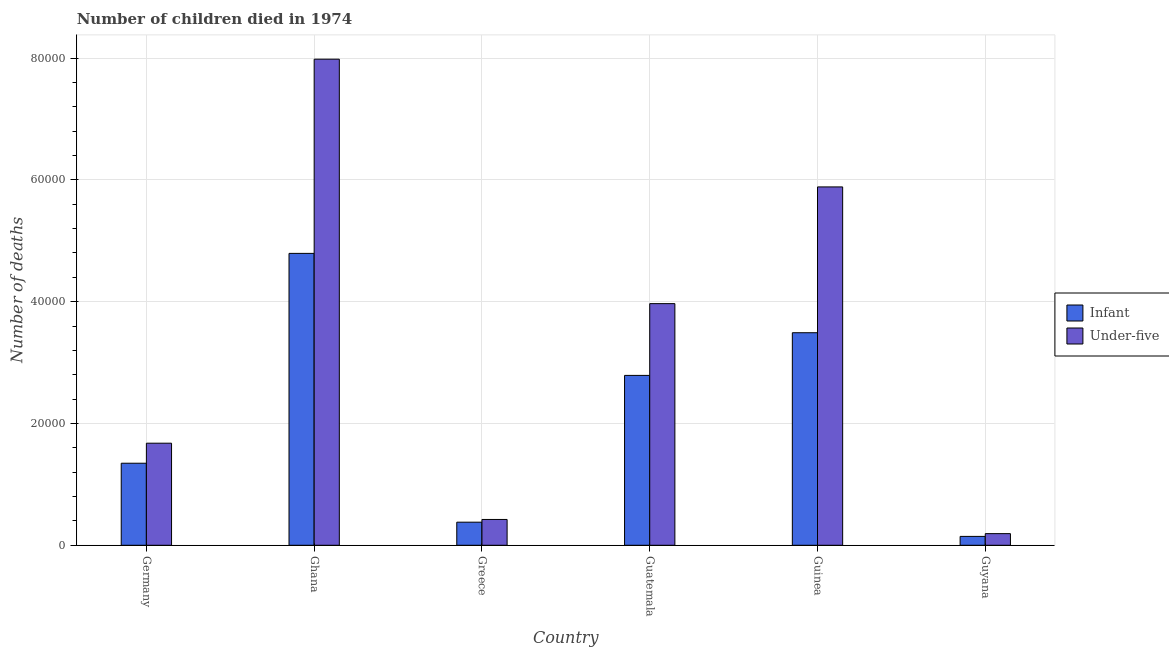How many different coloured bars are there?
Provide a short and direct response. 2. Are the number of bars per tick equal to the number of legend labels?
Your response must be concise. Yes. How many bars are there on the 3rd tick from the left?
Give a very brief answer. 2. What is the label of the 6th group of bars from the left?
Make the answer very short. Guyana. What is the number of infant deaths in Guatemala?
Keep it short and to the point. 2.79e+04. Across all countries, what is the maximum number of infant deaths?
Provide a succinct answer. 4.79e+04. Across all countries, what is the minimum number of under-five deaths?
Ensure brevity in your answer.  1912. In which country was the number of under-five deaths minimum?
Provide a short and direct response. Guyana. What is the total number of under-five deaths in the graph?
Your response must be concise. 2.01e+05. What is the difference between the number of under-five deaths in Germany and that in Ghana?
Make the answer very short. -6.30e+04. What is the difference between the number of infant deaths in Guinea and the number of under-five deaths in Guatemala?
Your answer should be compact. -4776. What is the average number of under-five deaths per country?
Keep it short and to the point. 3.35e+04. What is the difference between the number of infant deaths and number of under-five deaths in Germany?
Your answer should be compact. -3290. In how many countries, is the number of under-five deaths greater than 4000 ?
Provide a succinct answer. 5. What is the ratio of the number of infant deaths in Ghana to that in Guyana?
Your answer should be very brief. 32.89. Is the number of infant deaths in Guatemala less than that in Guyana?
Offer a very short reply. No. Is the difference between the number of infant deaths in Guinea and Guyana greater than the difference between the number of under-five deaths in Guinea and Guyana?
Provide a succinct answer. No. What is the difference between the highest and the second highest number of under-five deaths?
Ensure brevity in your answer.  2.10e+04. What is the difference between the highest and the lowest number of under-five deaths?
Provide a short and direct response. 7.79e+04. In how many countries, is the number of infant deaths greater than the average number of infant deaths taken over all countries?
Your answer should be very brief. 3. What does the 1st bar from the left in Guatemala represents?
Your response must be concise. Infant. What does the 1st bar from the right in Greece represents?
Give a very brief answer. Under-five. How many bars are there?
Offer a terse response. 12. Are all the bars in the graph horizontal?
Provide a succinct answer. No. Are the values on the major ticks of Y-axis written in scientific E-notation?
Your response must be concise. No. Does the graph contain any zero values?
Provide a short and direct response. No. How many legend labels are there?
Offer a very short reply. 2. What is the title of the graph?
Ensure brevity in your answer.  Number of children died in 1974. What is the label or title of the X-axis?
Give a very brief answer. Country. What is the label or title of the Y-axis?
Offer a very short reply. Number of deaths. What is the Number of deaths in Infant in Germany?
Offer a terse response. 1.35e+04. What is the Number of deaths in Under-five in Germany?
Your answer should be very brief. 1.68e+04. What is the Number of deaths in Infant in Ghana?
Ensure brevity in your answer.  4.79e+04. What is the Number of deaths of Under-five in Ghana?
Keep it short and to the point. 7.98e+04. What is the Number of deaths of Infant in Greece?
Your response must be concise. 3792. What is the Number of deaths in Under-five in Greece?
Your response must be concise. 4239. What is the Number of deaths in Infant in Guatemala?
Offer a very short reply. 2.79e+04. What is the Number of deaths in Under-five in Guatemala?
Your answer should be compact. 3.97e+04. What is the Number of deaths in Infant in Guinea?
Your answer should be compact. 3.49e+04. What is the Number of deaths of Under-five in Guinea?
Provide a succinct answer. 5.88e+04. What is the Number of deaths of Infant in Guyana?
Ensure brevity in your answer.  1457. What is the Number of deaths of Under-five in Guyana?
Make the answer very short. 1912. Across all countries, what is the maximum Number of deaths in Infant?
Make the answer very short. 4.79e+04. Across all countries, what is the maximum Number of deaths in Under-five?
Offer a very short reply. 7.98e+04. Across all countries, what is the minimum Number of deaths in Infant?
Your answer should be compact. 1457. Across all countries, what is the minimum Number of deaths in Under-five?
Your response must be concise. 1912. What is the total Number of deaths in Infant in the graph?
Make the answer very short. 1.29e+05. What is the total Number of deaths in Under-five in the graph?
Provide a short and direct response. 2.01e+05. What is the difference between the Number of deaths in Infant in Germany and that in Ghana?
Provide a succinct answer. -3.45e+04. What is the difference between the Number of deaths in Under-five in Germany and that in Ghana?
Provide a short and direct response. -6.30e+04. What is the difference between the Number of deaths of Infant in Germany and that in Greece?
Make the answer very short. 9678. What is the difference between the Number of deaths in Under-five in Germany and that in Greece?
Keep it short and to the point. 1.25e+04. What is the difference between the Number of deaths in Infant in Germany and that in Guatemala?
Offer a terse response. -1.44e+04. What is the difference between the Number of deaths of Under-five in Germany and that in Guatemala?
Your response must be concise. -2.29e+04. What is the difference between the Number of deaths of Infant in Germany and that in Guinea?
Make the answer very short. -2.14e+04. What is the difference between the Number of deaths of Under-five in Germany and that in Guinea?
Offer a very short reply. -4.21e+04. What is the difference between the Number of deaths of Infant in Germany and that in Guyana?
Keep it short and to the point. 1.20e+04. What is the difference between the Number of deaths of Under-five in Germany and that in Guyana?
Ensure brevity in your answer.  1.48e+04. What is the difference between the Number of deaths in Infant in Ghana and that in Greece?
Give a very brief answer. 4.41e+04. What is the difference between the Number of deaths in Under-five in Ghana and that in Greece?
Offer a terse response. 7.56e+04. What is the difference between the Number of deaths in Infant in Ghana and that in Guatemala?
Provide a short and direct response. 2.00e+04. What is the difference between the Number of deaths of Under-five in Ghana and that in Guatemala?
Provide a succinct answer. 4.01e+04. What is the difference between the Number of deaths in Infant in Ghana and that in Guinea?
Make the answer very short. 1.30e+04. What is the difference between the Number of deaths in Under-five in Ghana and that in Guinea?
Offer a very short reply. 2.10e+04. What is the difference between the Number of deaths of Infant in Ghana and that in Guyana?
Ensure brevity in your answer.  4.65e+04. What is the difference between the Number of deaths of Under-five in Ghana and that in Guyana?
Your answer should be compact. 7.79e+04. What is the difference between the Number of deaths of Infant in Greece and that in Guatemala?
Your answer should be compact. -2.41e+04. What is the difference between the Number of deaths in Under-five in Greece and that in Guatemala?
Your response must be concise. -3.54e+04. What is the difference between the Number of deaths of Infant in Greece and that in Guinea?
Your answer should be very brief. -3.11e+04. What is the difference between the Number of deaths of Under-five in Greece and that in Guinea?
Make the answer very short. -5.46e+04. What is the difference between the Number of deaths in Infant in Greece and that in Guyana?
Your answer should be very brief. 2335. What is the difference between the Number of deaths in Under-five in Greece and that in Guyana?
Offer a very short reply. 2327. What is the difference between the Number of deaths of Infant in Guatemala and that in Guinea?
Keep it short and to the point. -7005. What is the difference between the Number of deaths in Under-five in Guatemala and that in Guinea?
Your answer should be very brief. -1.92e+04. What is the difference between the Number of deaths in Infant in Guatemala and that in Guyana?
Your answer should be compact. 2.64e+04. What is the difference between the Number of deaths of Under-five in Guatemala and that in Guyana?
Give a very brief answer. 3.78e+04. What is the difference between the Number of deaths in Infant in Guinea and that in Guyana?
Keep it short and to the point. 3.34e+04. What is the difference between the Number of deaths of Under-five in Guinea and that in Guyana?
Make the answer very short. 5.69e+04. What is the difference between the Number of deaths in Infant in Germany and the Number of deaths in Under-five in Ghana?
Your answer should be very brief. -6.63e+04. What is the difference between the Number of deaths of Infant in Germany and the Number of deaths of Under-five in Greece?
Ensure brevity in your answer.  9231. What is the difference between the Number of deaths of Infant in Germany and the Number of deaths of Under-five in Guatemala?
Offer a terse response. -2.62e+04. What is the difference between the Number of deaths of Infant in Germany and the Number of deaths of Under-five in Guinea?
Give a very brief answer. -4.54e+04. What is the difference between the Number of deaths of Infant in Germany and the Number of deaths of Under-five in Guyana?
Provide a succinct answer. 1.16e+04. What is the difference between the Number of deaths in Infant in Ghana and the Number of deaths in Under-five in Greece?
Ensure brevity in your answer.  4.37e+04. What is the difference between the Number of deaths in Infant in Ghana and the Number of deaths in Under-five in Guatemala?
Provide a short and direct response. 8252. What is the difference between the Number of deaths of Infant in Ghana and the Number of deaths of Under-five in Guinea?
Provide a short and direct response. -1.09e+04. What is the difference between the Number of deaths in Infant in Ghana and the Number of deaths in Under-five in Guyana?
Your response must be concise. 4.60e+04. What is the difference between the Number of deaths in Infant in Greece and the Number of deaths in Under-five in Guatemala?
Keep it short and to the point. -3.59e+04. What is the difference between the Number of deaths of Infant in Greece and the Number of deaths of Under-five in Guinea?
Your response must be concise. -5.50e+04. What is the difference between the Number of deaths in Infant in Greece and the Number of deaths in Under-five in Guyana?
Keep it short and to the point. 1880. What is the difference between the Number of deaths of Infant in Guatemala and the Number of deaths of Under-five in Guinea?
Ensure brevity in your answer.  -3.09e+04. What is the difference between the Number of deaths in Infant in Guatemala and the Number of deaths in Under-five in Guyana?
Your answer should be very brief. 2.60e+04. What is the difference between the Number of deaths of Infant in Guinea and the Number of deaths of Under-five in Guyana?
Offer a very short reply. 3.30e+04. What is the average Number of deaths in Infant per country?
Your response must be concise. 2.16e+04. What is the average Number of deaths in Under-five per country?
Offer a very short reply. 3.35e+04. What is the difference between the Number of deaths of Infant and Number of deaths of Under-five in Germany?
Make the answer very short. -3290. What is the difference between the Number of deaths of Infant and Number of deaths of Under-five in Ghana?
Ensure brevity in your answer.  -3.19e+04. What is the difference between the Number of deaths of Infant and Number of deaths of Under-five in Greece?
Provide a short and direct response. -447. What is the difference between the Number of deaths in Infant and Number of deaths in Under-five in Guatemala?
Offer a terse response. -1.18e+04. What is the difference between the Number of deaths of Infant and Number of deaths of Under-five in Guinea?
Make the answer very short. -2.39e+04. What is the difference between the Number of deaths of Infant and Number of deaths of Under-five in Guyana?
Make the answer very short. -455. What is the ratio of the Number of deaths in Infant in Germany to that in Ghana?
Provide a succinct answer. 0.28. What is the ratio of the Number of deaths in Under-five in Germany to that in Ghana?
Your answer should be compact. 0.21. What is the ratio of the Number of deaths in Infant in Germany to that in Greece?
Your response must be concise. 3.55. What is the ratio of the Number of deaths of Under-five in Germany to that in Greece?
Your answer should be very brief. 3.95. What is the ratio of the Number of deaths of Infant in Germany to that in Guatemala?
Provide a succinct answer. 0.48. What is the ratio of the Number of deaths of Under-five in Germany to that in Guatemala?
Offer a very short reply. 0.42. What is the ratio of the Number of deaths in Infant in Germany to that in Guinea?
Provide a succinct answer. 0.39. What is the ratio of the Number of deaths in Under-five in Germany to that in Guinea?
Provide a short and direct response. 0.28. What is the ratio of the Number of deaths of Infant in Germany to that in Guyana?
Make the answer very short. 9.24. What is the ratio of the Number of deaths of Under-five in Germany to that in Guyana?
Provide a short and direct response. 8.77. What is the ratio of the Number of deaths in Infant in Ghana to that in Greece?
Your answer should be very brief. 12.64. What is the ratio of the Number of deaths in Under-five in Ghana to that in Greece?
Make the answer very short. 18.83. What is the ratio of the Number of deaths in Infant in Ghana to that in Guatemala?
Keep it short and to the point. 1.72. What is the ratio of the Number of deaths in Under-five in Ghana to that in Guatemala?
Make the answer very short. 2.01. What is the ratio of the Number of deaths of Infant in Ghana to that in Guinea?
Provide a short and direct response. 1.37. What is the ratio of the Number of deaths of Under-five in Ghana to that in Guinea?
Your answer should be compact. 1.36. What is the ratio of the Number of deaths of Infant in Ghana to that in Guyana?
Ensure brevity in your answer.  32.89. What is the ratio of the Number of deaths in Under-five in Ghana to that in Guyana?
Your response must be concise. 41.74. What is the ratio of the Number of deaths in Infant in Greece to that in Guatemala?
Provide a short and direct response. 0.14. What is the ratio of the Number of deaths in Under-five in Greece to that in Guatemala?
Your response must be concise. 0.11. What is the ratio of the Number of deaths of Infant in Greece to that in Guinea?
Make the answer very short. 0.11. What is the ratio of the Number of deaths in Under-five in Greece to that in Guinea?
Keep it short and to the point. 0.07. What is the ratio of the Number of deaths in Infant in Greece to that in Guyana?
Ensure brevity in your answer.  2.6. What is the ratio of the Number of deaths in Under-five in Greece to that in Guyana?
Keep it short and to the point. 2.22. What is the ratio of the Number of deaths in Infant in Guatemala to that in Guinea?
Give a very brief answer. 0.8. What is the ratio of the Number of deaths of Under-five in Guatemala to that in Guinea?
Ensure brevity in your answer.  0.67. What is the ratio of the Number of deaths in Infant in Guatemala to that in Guyana?
Offer a very short reply. 19.14. What is the ratio of the Number of deaths of Under-five in Guatemala to that in Guyana?
Your response must be concise. 20.75. What is the ratio of the Number of deaths of Infant in Guinea to that in Guyana?
Keep it short and to the point. 23.95. What is the ratio of the Number of deaths of Under-five in Guinea to that in Guyana?
Your answer should be very brief. 30.77. What is the difference between the highest and the second highest Number of deaths of Infant?
Your response must be concise. 1.30e+04. What is the difference between the highest and the second highest Number of deaths in Under-five?
Your answer should be very brief. 2.10e+04. What is the difference between the highest and the lowest Number of deaths of Infant?
Make the answer very short. 4.65e+04. What is the difference between the highest and the lowest Number of deaths of Under-five?
Make the answer very short. 7.79e+04. 